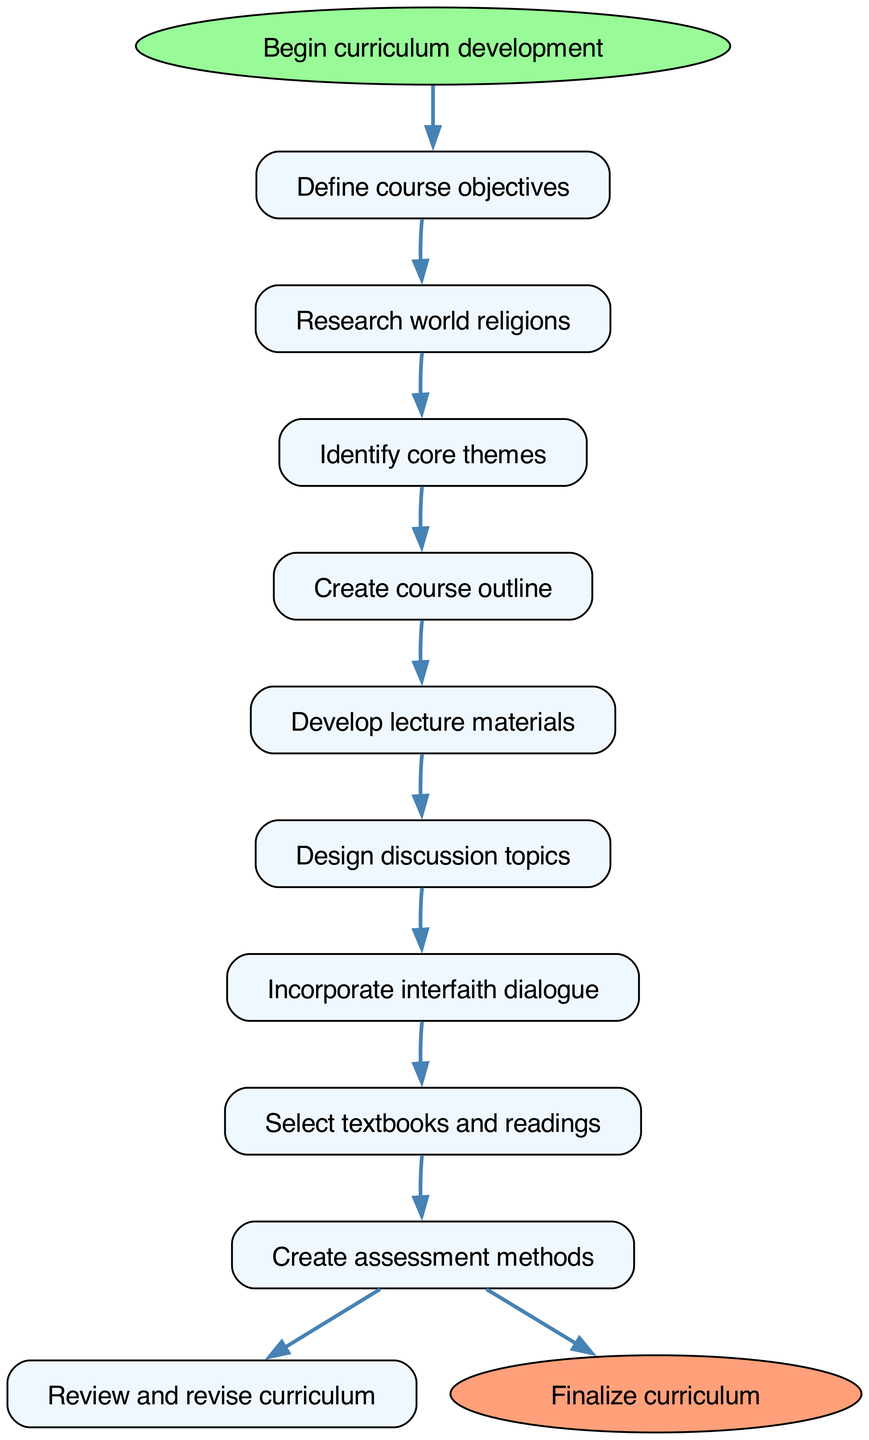What is the starting point of the curriculum development process? The starting point is indicated by the node labeled "Begin curriculum development." This node serves as the entry point for the flow chart and initiates the process.
Answer: Begin curriculum development How many steps are there in the curriculum development process? By counting the individual steps listed in the diagram, we find that there are a total of nine distinct steps leading from the beginning to the final curriculum.
Answer: 9 What step comes after "Design discussion topics"? The diagram indicates that the next step following "Design discussion topics" is "Incorporate interfaith dialogue," which is linked by an arrow to show the sequence of the process.
Answer: Incorporate interfaith dialogue What is the final step in the curriculum development process? The final step is represented by the node "Finalize curriculum." This effectively concludes the curriculum development process, indicating that all prior steps have been completed.
Answer: Finalize curriculum Which step involves selecting educational materials? The step that involves selecting educational materials is "Select textbooks and readings." This step is positioned before the assessment methods in the flow of the curriculum development.
Answer: Select textbooks and readings What is the relationship between "Create course outline" and "Develop lecture materials"? The relationship is sequential; the arrow shows that after completing "Create course outline," the next action in the process is "Develop lecture materials," evidencing the flow of progression in curriculum design.
Answer: Sequential relationship How does interfaith dialogue relate to the overall curriculum? "Incorporate interfaith dialogue" is an integral part of the curriculum development process, specifically arising after designing discussion topics, to enhance understanding and promote tolerance among different religions.
Answer: Integral part What action must be taken after developing lecture materials? After developing lecture materials, the subsequent action required is "Design discussion topics," indicating that the flow requires these topics to be established next.
Answer: Design discussion topics What theme is identified before creating the course outline? The theme that must be identified before creating the course outline is "Identify core themes." This step ensures that the course is structured around central ideas before developing further content.
Answer: Identify core themes 